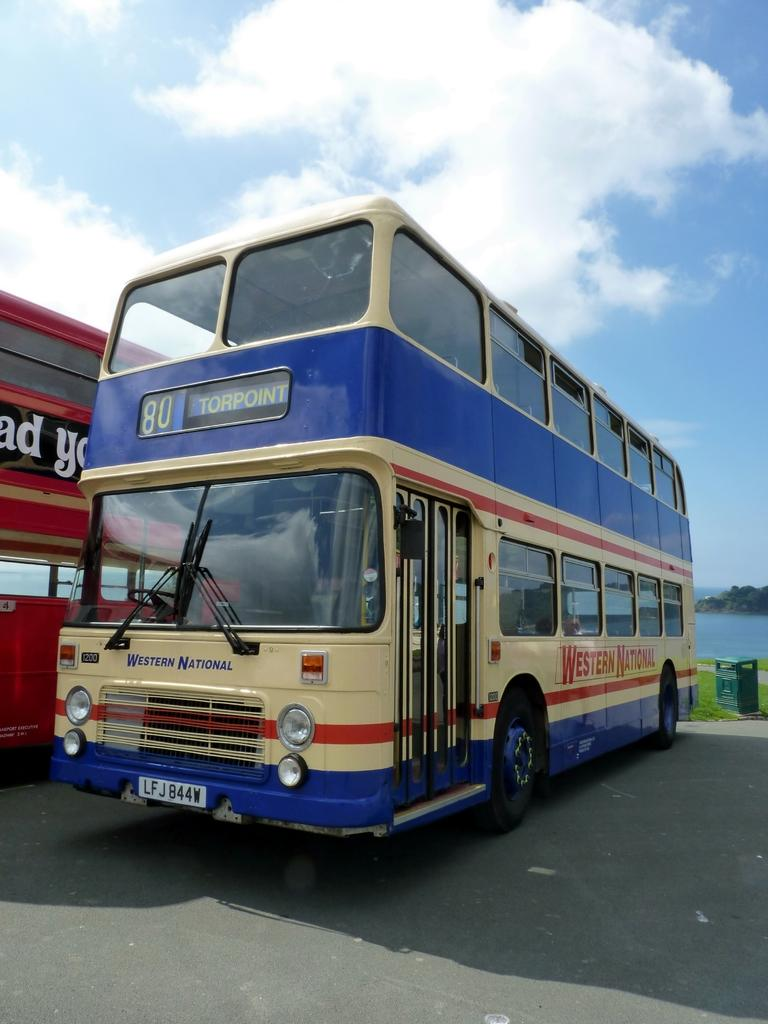What type of vehicles can be seen on the road in the image? There are buses on the road in the image. What object can be seen on the ground in the background? There is a trash bin on the ground in the background. What natural features are visible in the background? Mountains and water are visible in the background. What is visible in the sky in the background? The sky is visible with clouds in the background. Can you describe the comfort of the wren sitting on the bus in the image? There is no wren present in the image, so we cannot describe its comfort. 